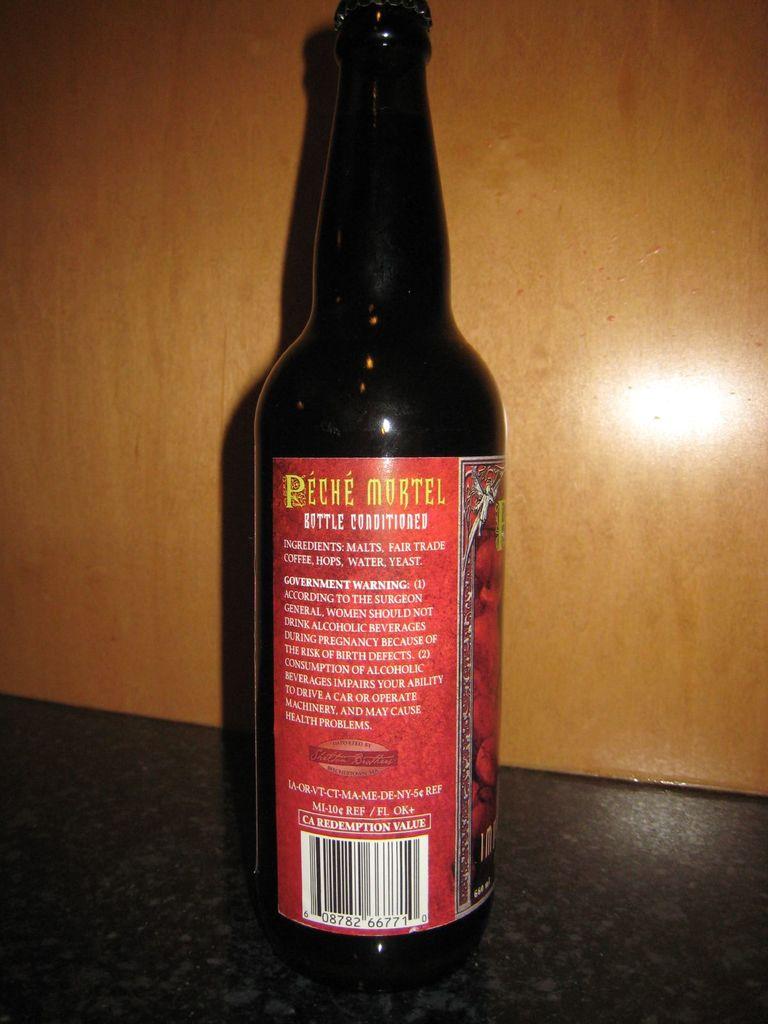What kind of drink is this?
Keep it short and to the point. Beer. 